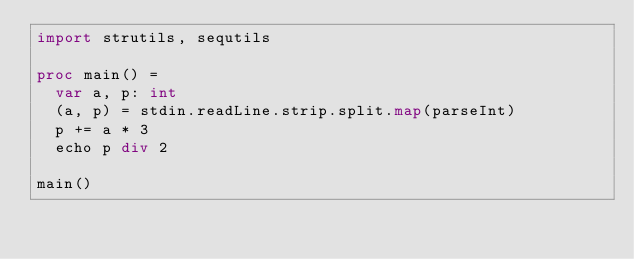Convert code to text. <code><loc_0><loc_0><loc_500><loc_500><_Nim_>import strutils, sequtils

proc main() =
  var a, p: int
  (a, p) = stdin.readLine.strip.split.map(parseInt)
  p += a * 3
  echo p div 2

main()
</code> 